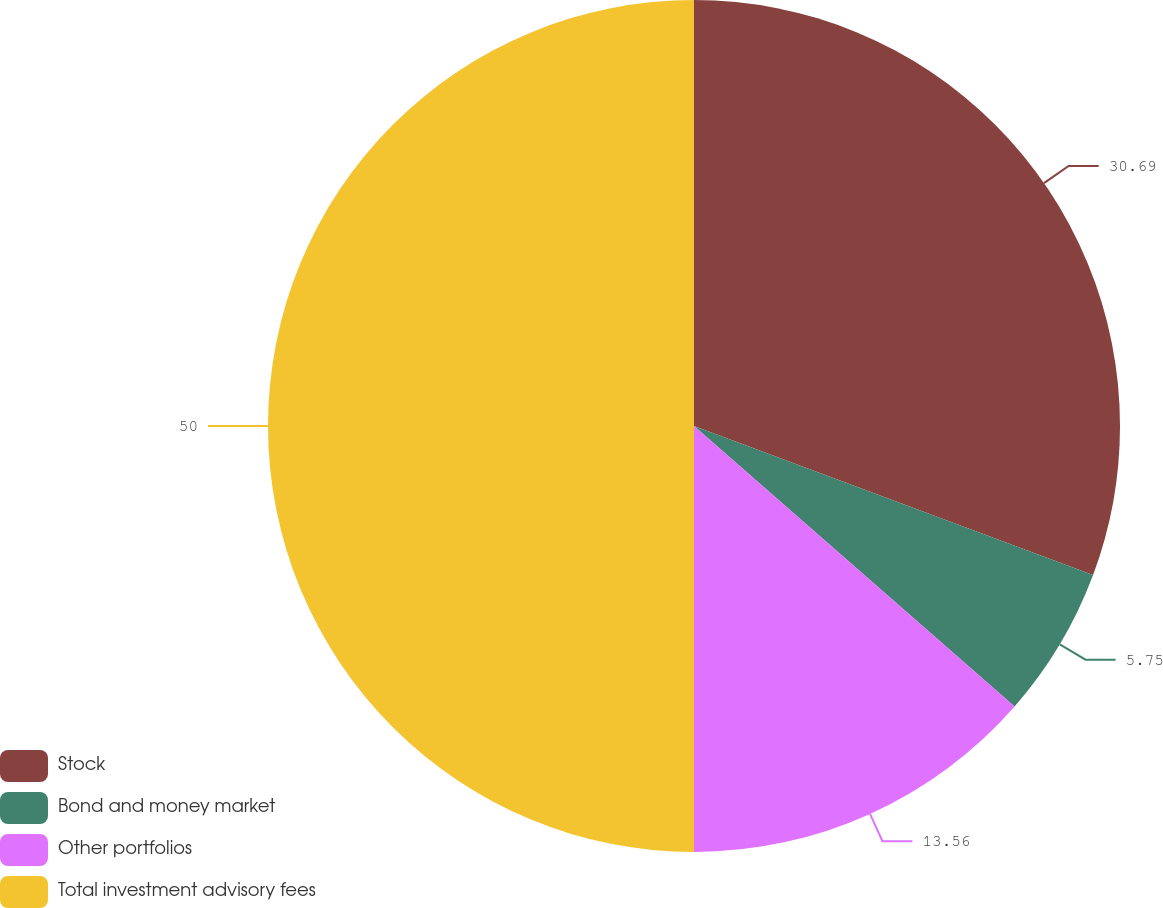<chart> <loc_0><loc_0><loc_500><loc_500><pie_chart><fcel>Stock<fcel>Bond and money market<fcel>Other portfolios<fcel>Total investment advisory fees<nl><fcel>30.69%<fcel>5.75%<fcel>13.56%<fcel>50.0%<nl></chart> 